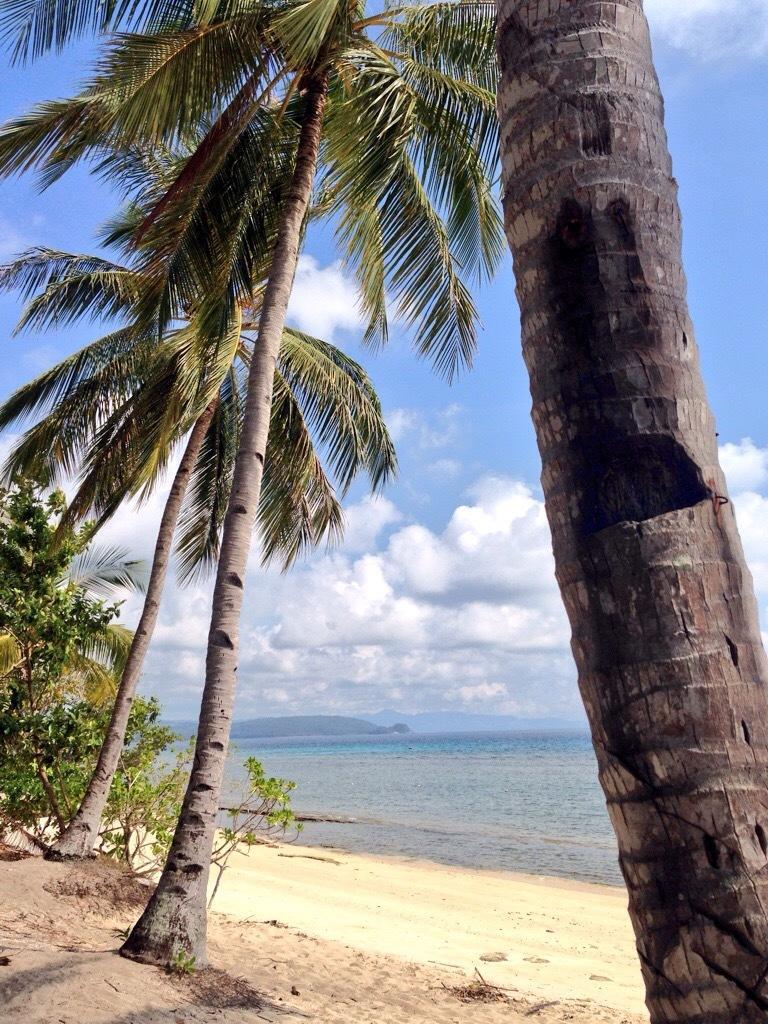Describe this image in one or two sentences. In this image there are trees, and, water, hills,sky. 